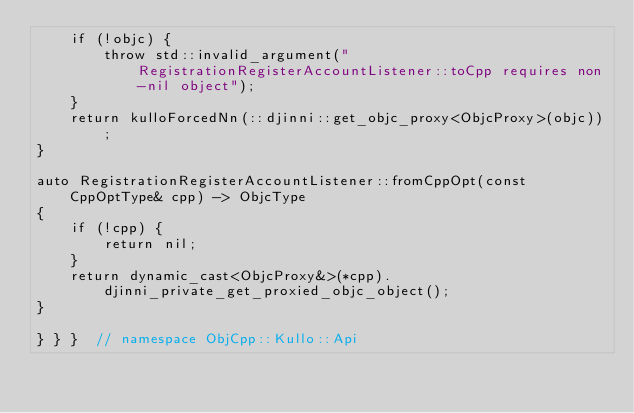<code> <loc_0><loc_0><loc_500><loc_500><_ObjectiveC_>    if (!objc) {
        throw std::invalid_argument("RegistrationRegisterAccountListener::toCpp requires non-nil object");
    }
    return kulloForcedNn(::djinni::get_objc_proxy<ObjcProxy>(objc));
}

auto RegistrationRegisterAccountListener::fromCppOpt(const CppOptType& cpp) -> ObjcType
{
    if (!cpp) {
        return nil;
    }
    return dynamic_cast<ObjcProxy&>(*cpp).djinni_private_get_proxied_objc_object();
}

} } }  // namespace ObjCpp::Kullo::Api
</code> 